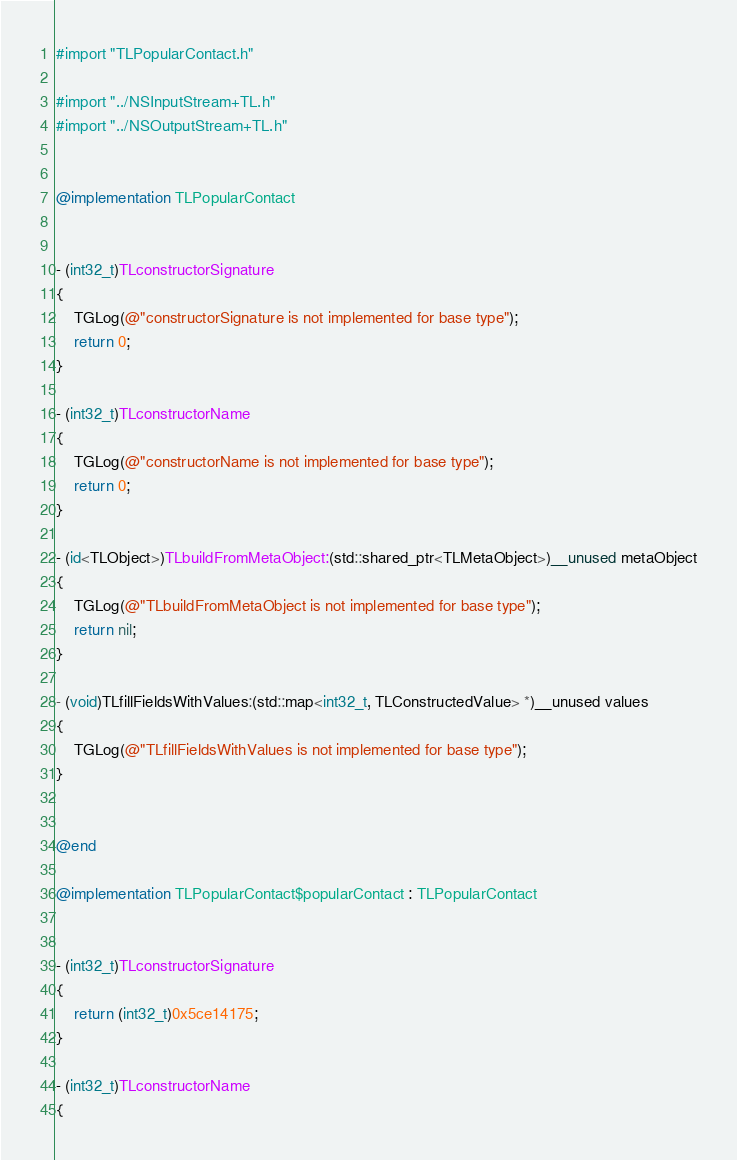Convert code to text. <code><loc_0><loc_0><loc_500><loc_500><_ObjectiveC_>#import "TLPopularContact.h"

#import "../NSInputStream+TL.h"
#import "../NSOutputStream+TL.h"


@implementation TLPopularContact


- (int32_t)TLconstructorSignature
{
    TGLog(@"constructorSignature is not implemented for base type");
    return 0;
}

- (int32_t)TLconstructorName
{
    TGLog(@"constructorName is not implemented for base type");
    return 0;
}

- (id<TLObject>)TLbuildFromMetaObject:(std::shared_ptr<TLMetaObject>)__unused metaObject
{
    TGLog(@"TLbuildFromMetaObject is not implemented for base type");
    return nil;
}

- (void)TLfillFieldsWithValues:(std::map<int32_t, TLConstructedValue> *)__unused values
{
    TGLog(@"TLfillFieldsWithValues is not implemented for base type");
}


@end

@implementation TLPopularContact$popularContact : TLPopularContact


- (int32_t)TLconstructorSignature
{
    return (int32_t)0x5ce14175;
}

- (int32_t)TLconstructorName
{</code> 